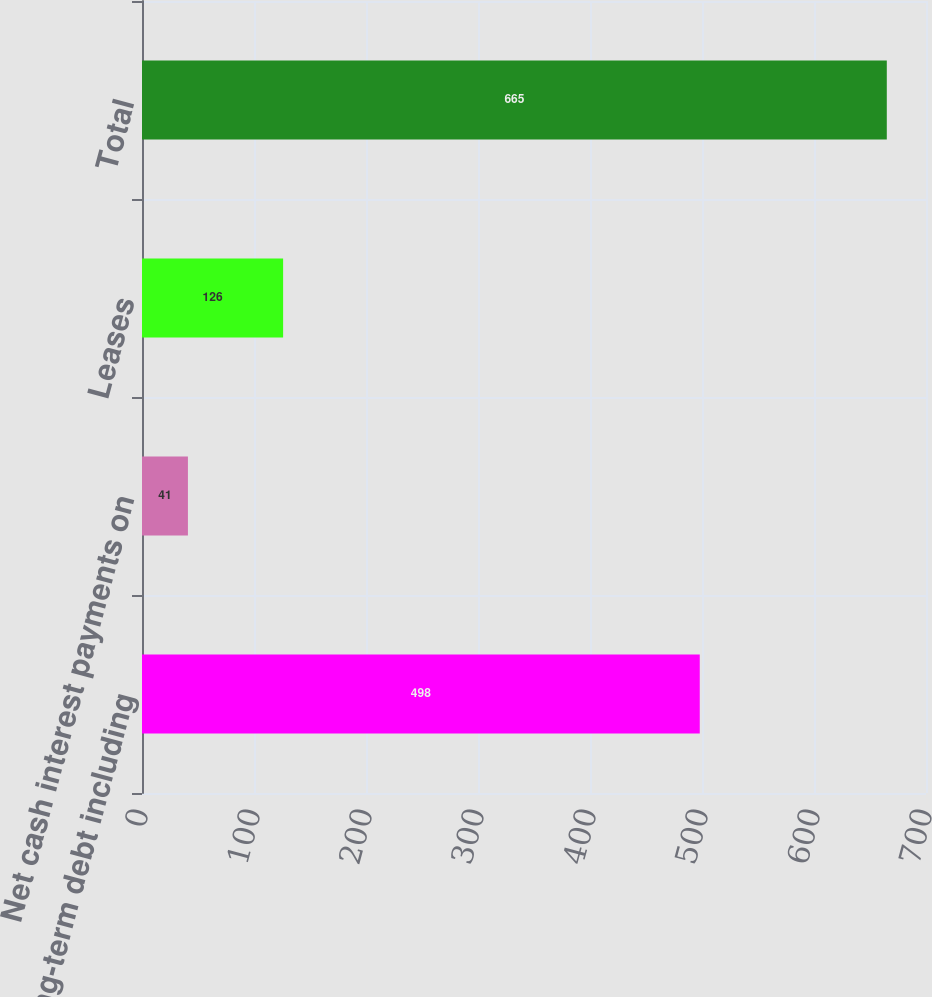Convert chart to OTSL. <chart><loc_0><loc_0><loc_500><loc_500><bar_chart><fcel>Long-term debt including<fcel>Net cash interest payments on<fcel>Leases<fcel>Total<nl><fcel>498<fcel>41<fcel>126<fcel>665<nl></chart> 